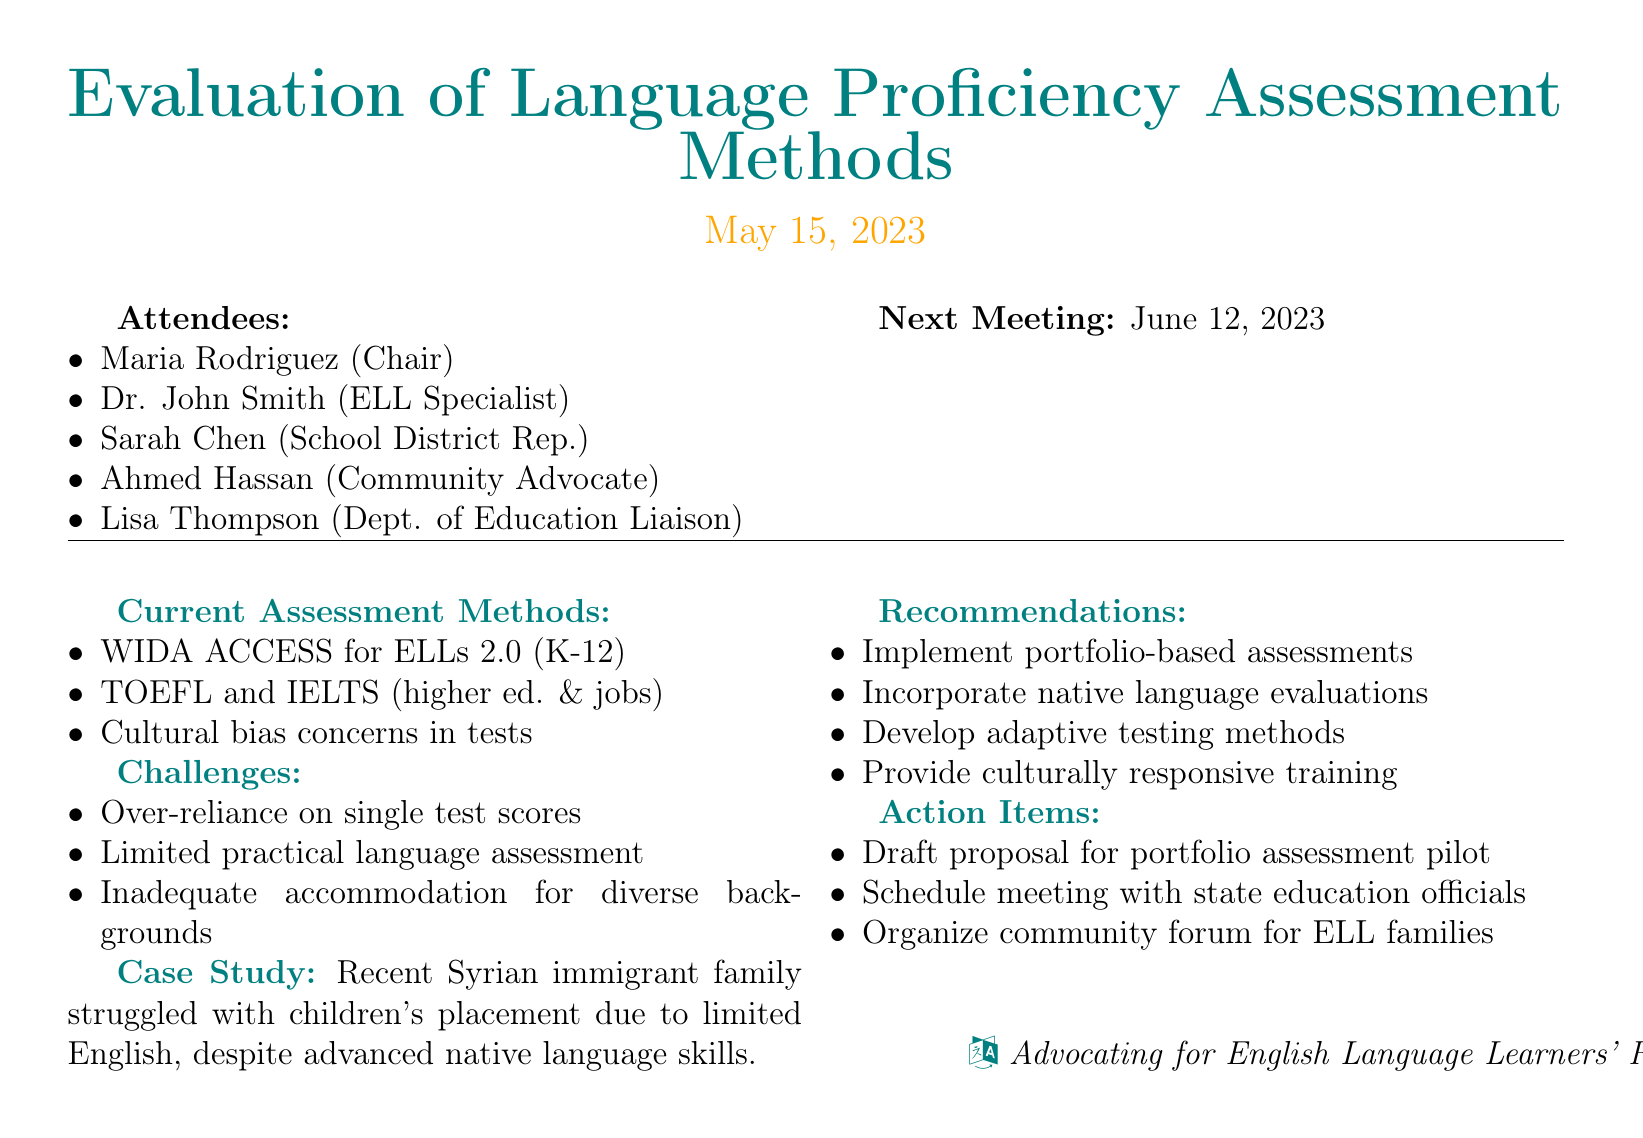What is the date of the meeting? The date of the meeting is stated in the document as "May 15, 2023."
Answer: May 15, 2023 Who is the Chair of the meeting? The document lists "Maria Rodriguez" as the Chair of the meeting.
Answer: Maria Rodriguez What assessment method is used in K-12 schools? "WIDA ACCESS for ELLs 2.0" is mentioned as the assessment method used in K-12 schools.
Answer: WIDA ACCESS for ELLs 2.0 What is a concern raised about standardized tests? The document indicates "Cultural bias" as a concern raised about standardized tests.
Answer: Cultural bias What type of assessment does the recommendation suggest implementing? The recommendations include "portfolio-based assessments" as a suggested type of assessment.
Answer: portfolio-based assessments Which immigrant family struggled with educational placement? The document refers to a "Recent immigrant family from Syria" that had struggles with placement.
Answer: Syrian How many action items are listed? The document lists "three" action items under the action items section.
Answer: three When is the next meeting scheduled? The next meeting date is specified as "June 12, 2023."
Answer: June 12, 2023 What is the role of Ahmed Hassan in the meeting? Ahmed Hassan is identified as a "Community Advocate" in the list of attendees.
Answer: Community Advocate 